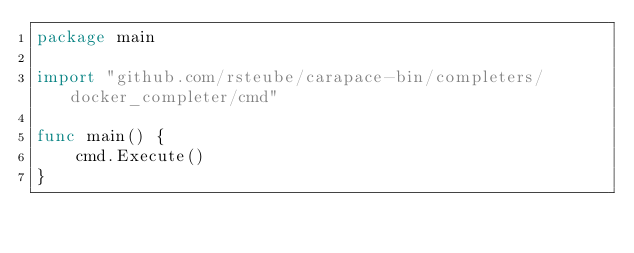Convert code to text. <code><loc_0><loc_0><loc_500><loc_500><_Go_>package main

import "github.com/rsteube/carapace-bin/completers/docker_completer/cmd"

func main() {
	cmd.Execute()
}
</code> 